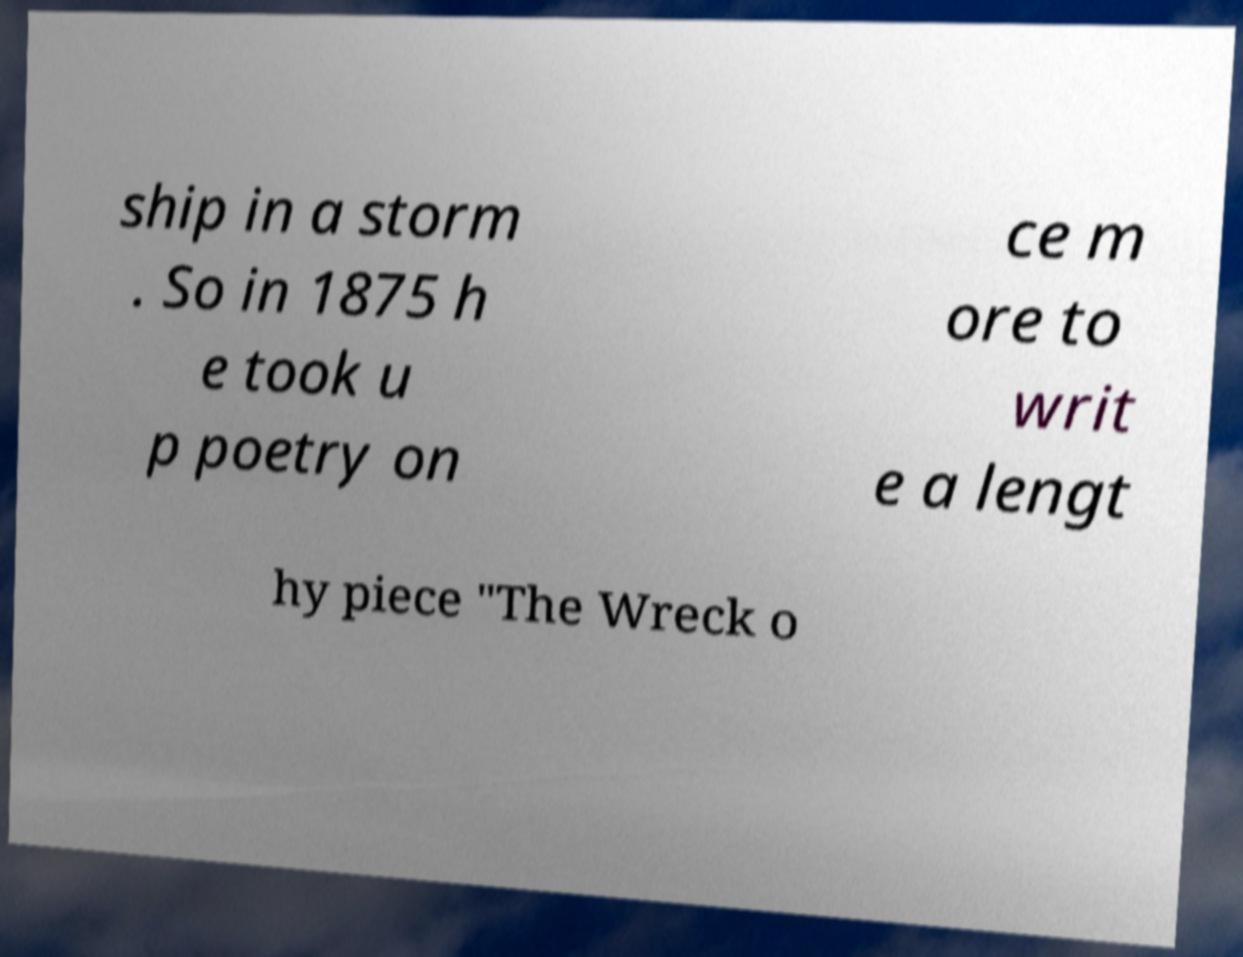Please identify and transcribe the text found in this image. ship in a storm . So in 1875 h e took u p poetry on ce m ore to writ e a lengt hy piece "The Wreck o 